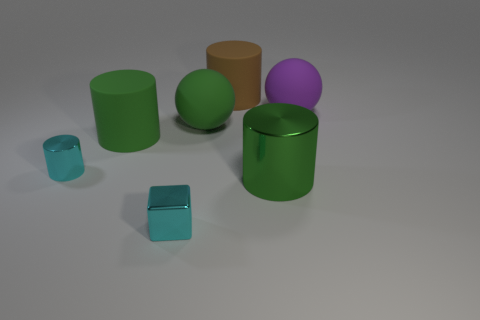What number of other things are the same material as the large brown cylinder?
Provide a succinct answer. 3. Are there any large blue balls?
Your answer should be compact. No. Do the green cylinder that is to the left of the big green shiny thing and the large purple object have the same material?
Your answer should be very brief. Yes. What material is the other big green thing that is the same shape as the large metallic object?
Your answer should be compact. Rubber. There is a tiny thing that is the same color as the block; what is it made of?
Your answer should be very brief. Metal. Is the number of matte things less than the number of tiny red cubes?
Offer a very short reply. No. There is a large rubber thing that is behind the large purple thing; is its color the same as the small shiny cylinder?
Offer a terse response. No. There is another large ball that is made of the same material as the large green ball; what color is it?
Offer a very short reply. Purple. Do the brown thing and the purple rubber object have the same size?
Your answer should be very brief. Yes. What is the small block made of?
Offer a very short reply. Metal. 